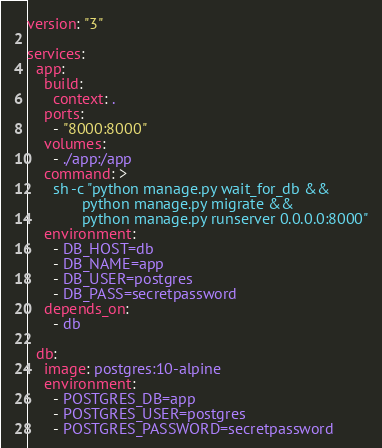Convert code to text. <code><loc_0><loc_0><loc_500><loc_500><_YAML_>version: "3"

services:
  app:
    build:
      context: .
    ports:
      - "8000:8000"
    volumes:
      - ./app:/app
    command: >
      sh -c "python manage.py wait_for_db &&
             python manage.py migrate &&
             python manage.py runserver 0.0.0.0:8000"
    environment:
      - DB_HOST=db
      - DB_NAME=app
      - DB_USER=postgres
      - DB_PASS=secretpassword
    depends_on:
      - db

  db:
    image: postgres:10-alpine
    environment:
      - POSTGRES_DB=app
      - POSTGRES_USER=postgres
      - POSTGRES_PASSWORD=secretpassword</code> 